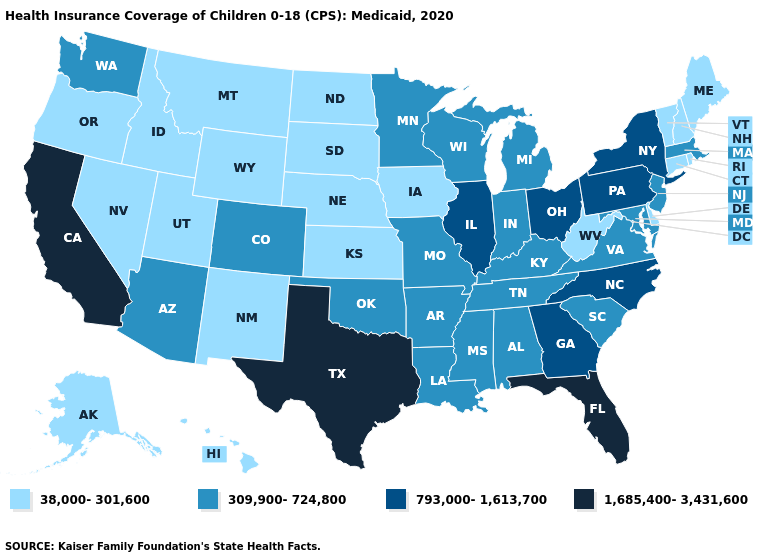Does Rhode Island have the same value as Wyoming?
Be succinct. Yes. Among the states that border Colorado , does Oklahoma have the lowest value?
Keep it brief. No. Does New Mexico have the lowest value in the USA?
Keep it brief. Yes. Among the states that border Alabama , does Mississippi have the lowest value?
Give a very brief answer. Yes. Name the states that have a value in the range 38,000-301,600?
Answer briefly. Alaska, Connecticut, Delaware, Hawaii, Idaho, Iowa, Kansas, Maine, Montana, Nebraska, Nevada, New Hampshire, New Mexico, North Dakota, Oregon, Rhode Island, South Dakota, Utah, Vermont, West Virginia, Wyoming. What is the value of Alaska?
Concise answer only. 38,000-301,600. What is the highest value in the Northeast ?
Be succinct. 793,000-1,613,700. Name the states that have a value in the range 38,000-301,600?
Quick response, please. Alaska, Connecticut, Delaware, Hawaii, Idaho, Iowa, Kansas, Maine, Montana, Nebraska, Nevada, New Hampshire, New Mexico, North Dakota, Oregon, Rhode Island, South Dakota, Utah, Vermont, West Virginia, Wyoming. Is the legend a continuous bar?
Keep it brief. No. What is the highest value in states that border South Carolina?
Quick response, please. 793,000-1,613,700. Is the legend a continuous bar?
Concise answer only. No. Does Texas have a lower value than California?
Keep it brief. No. Does South Dakota have the highest value in the MidWest?
Short answer required. No. What is the highest value in states that border North Carolina?
Concise answer only. 793,000-1,613,700. Name the states that have a value in the range 38,000-301,600?
Keep it brief. Alaska, Connecticut, Delaware, Hawaii, Idaho, Iowa, Kansas, Maine, Montana, Nebraska, Nevada, New Hampshire, New Mexico, North Dakota, Oregon, Rhode Island, South Dakota, Utah, Vermont, West Virginia, Wyoming. 